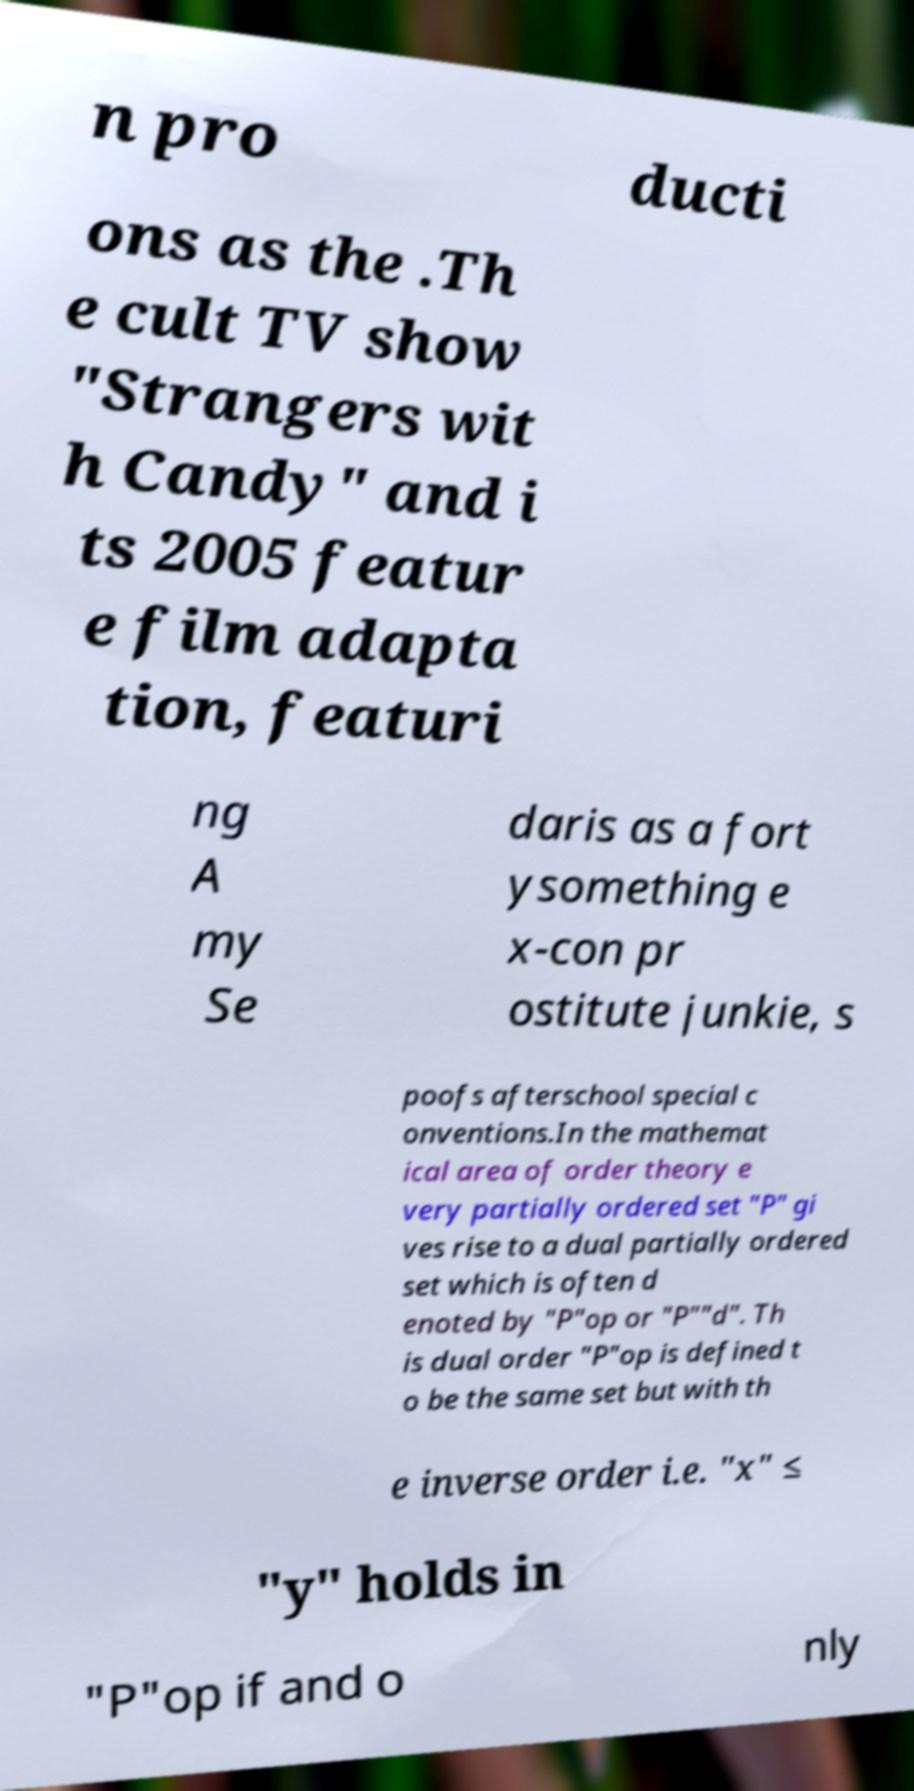For documentation purposes, I need the text within this image transcribed. Could you provide that? n pro ducti ons as the .Th e cult TV show "Strangers wit h Candy" and i ts 2005 featur e film adapta tion, featuri ng A my Se daris as a fort ysomething e x-con pr ostitute junkie, s poofs afterschool special c onventions.In the mathemat ical area of order theory e very partially ordered set "P" gi ves rise to a dual partially ordered set which is often d enoted by "P"op or "P""d". Th is dual order "P"op is defined t o be the same set but with th e inverse order i.e. "x" ≤ "y" holds in "P"op if and o nly 